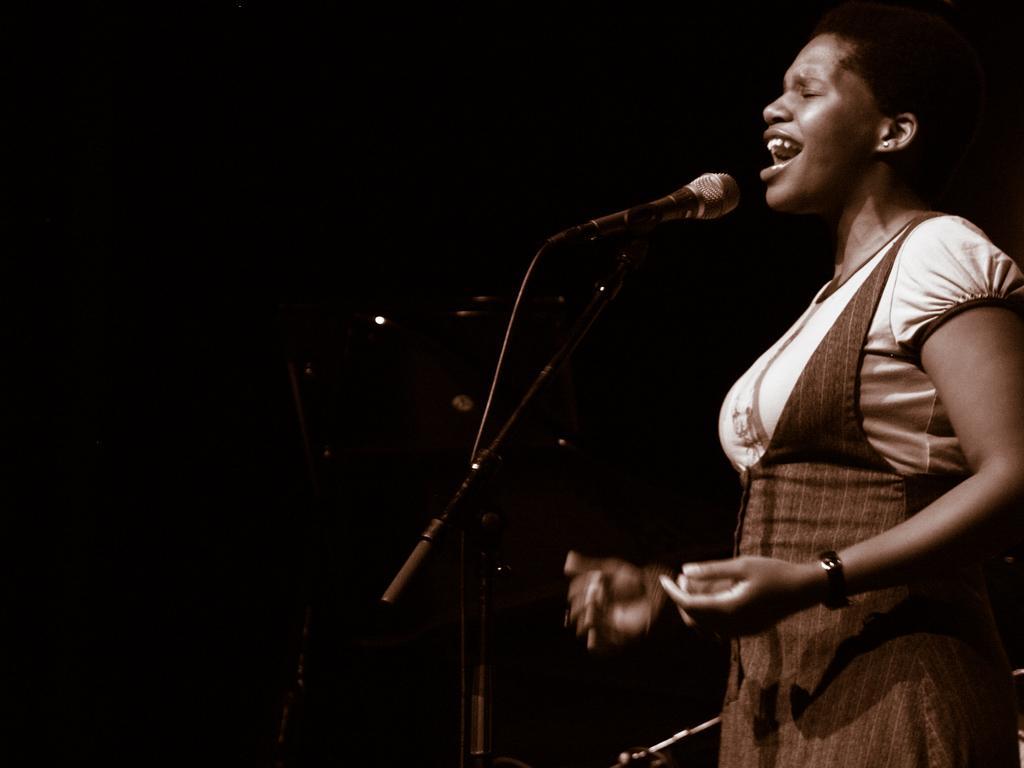Could you give a brief overview of what you see in this image? In this picture I can see a woman who is standing in front of a tripod, on which there is a mic. I see that it is dark in the background. 